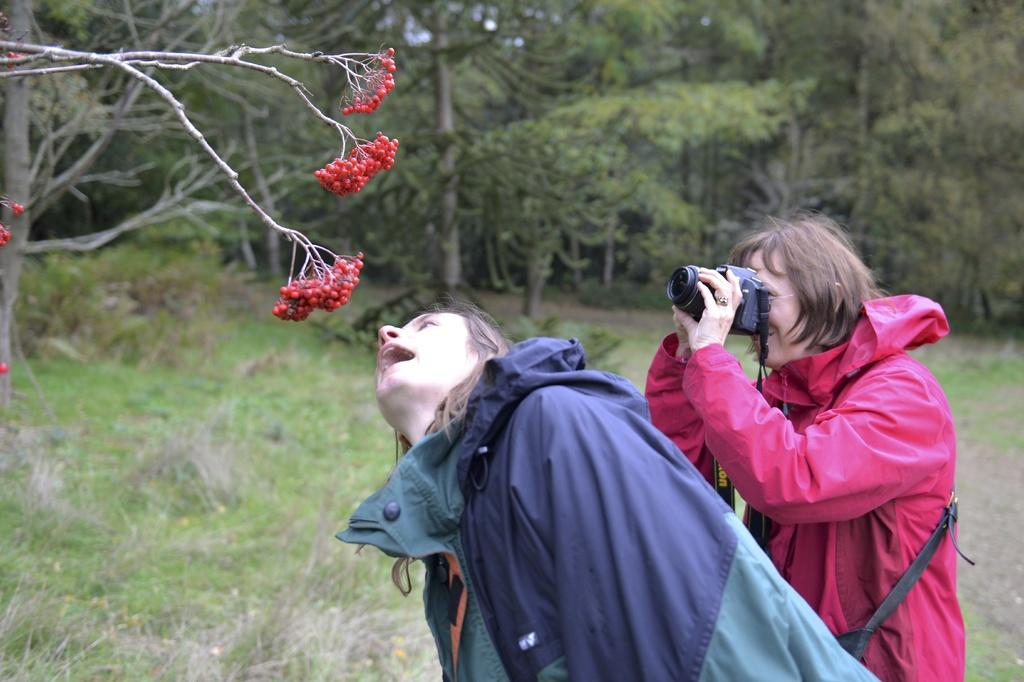What type of vegetation is present in the image? There is green grass in the image. What else can be seen in the image besides the grass? There are trees in the image. How many people are in the image? There are two people in the image. What is the person on the right side of the image holding? The person on the right side of the image is holding a camera. How much money is being exchanged between the two people in the image? There is no indication of money being exchanged between the two people in the image. What type of transport is visible in the image? There is no transport visible in the image. 